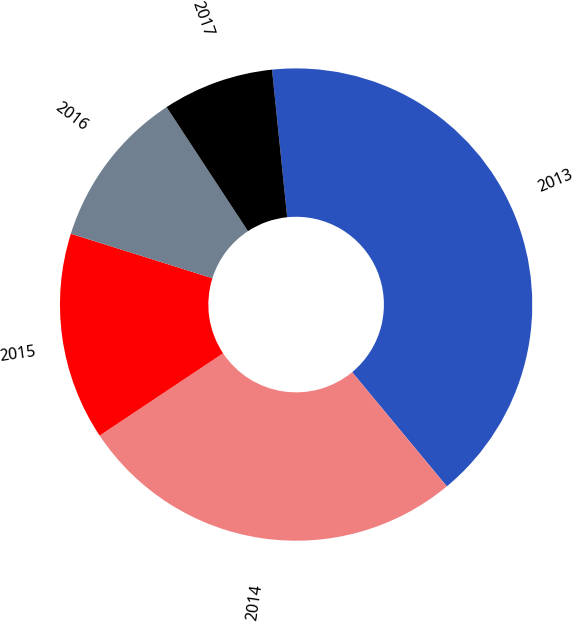<chart> <loc_0><loc_0><loc_500><loc_500><pie_chart><fcel>2013<fcel>2014<fcel>2015<fcel>2016<fcel>2017<nl><fcel>40.61%<fcel>26.65%<fcel>14.21%<fcel>10.91%<fcel>7.61%<nl></chart> 